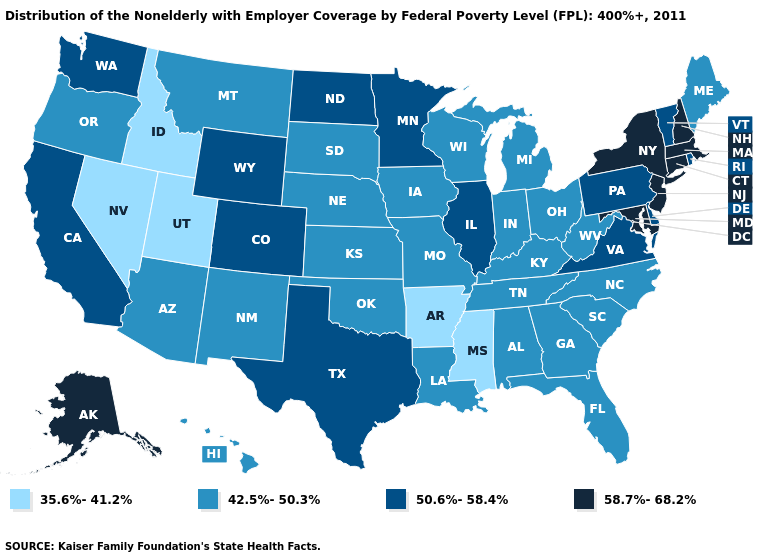What is the highest value in states that border Vermont?
Give a very brief answer. 58.7%-68.2%. Does Wyoming have a lower value than Alaska?
Keep it brief. Yes. Which states hav the highest value in the MidWest?
Keep it brief. Illinois, Minnesota, North Dakota. What is the value of Minnesota?
Answer briefly. 50.6%-58.4%. Which states have the highest value in the USA?
Keep it brief. Alaska, Connecticut, Maryland, Massachusetts, New Hampshire, New Jersey, New York. Which states hav the highest value in the MidWest?
Be succinct. Illinois, Minnesota, North Dakota. Does New Hampshire have the highest value in the USA?
Be succinct. Yes. Name the states that have a value in the range 35.6%-41.2%?
Concise answer only. Arkansas, Idaho, Mississippi, Nevada, Utah. Name the states that have a value in the range 42.5%-50.3%?
Be succinct. Alabama, Arizona, Florida, Georgia, Hawaii, Indiana, Iowa, Kansas, Kentucky, Louisiana, Maine, Michigan, Missouri, Montana, Nebraska, New Mexico, North Carolina, Ohio, Oklahoma, Oregon, South Carolina, South Dakota, Tennessee, West Virginia, Wisconsin. Name the states that have a value in the range 58.7%-68.2%?
Keep it brief. Alaska, Connecticut, Maryland, Massachusetts, New Hampshire, New Jersey, New York. Does Ohio have the highest value in the MidWest?
Concise answer only. No. What is the value of Wisconsin?
Quick response, please. 42.5%-50.3%. What is the value of Massachusetts?
Write a very short answer. 58.7%-68.2%. Name the states that have a value in the range 58.7%-68.2%?
Write a very short answer. Alaska, Connecticut, Maryland, Massachusetts, New Hampshire, New Jersey, New York. Does North Dakota have the highest value in the MidWest?
Give a very brief answer. Yes. 